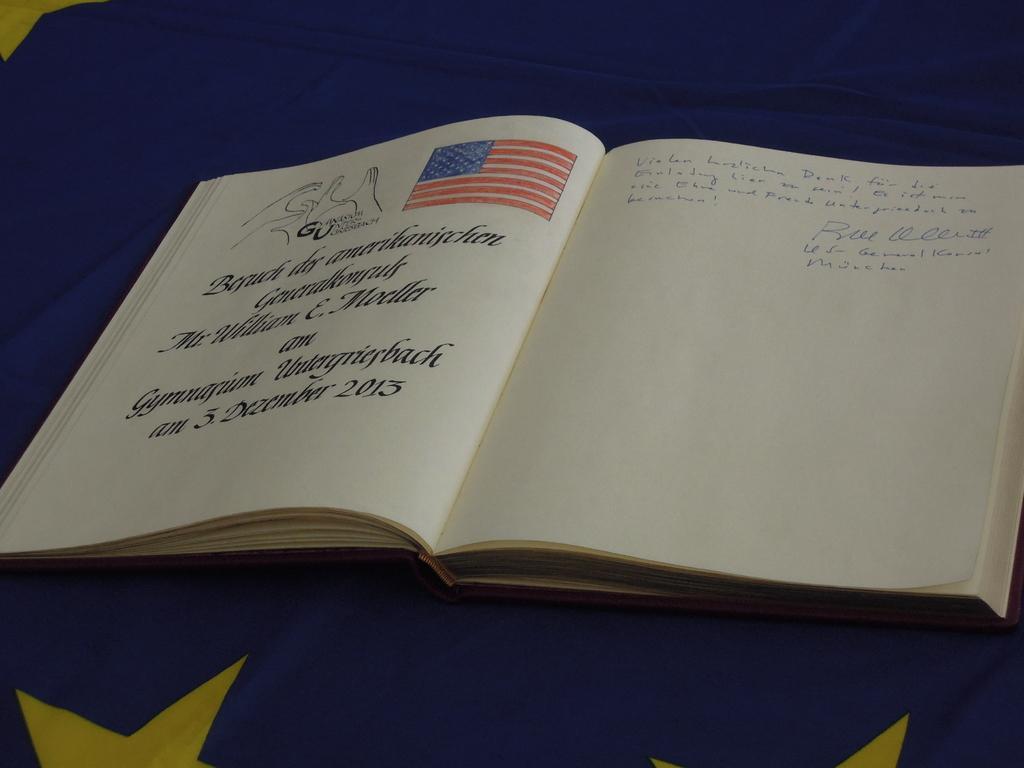Please provide a concise description of this image. In this image we can see a book containing some pictures and text in it which is placed on a cloth. 